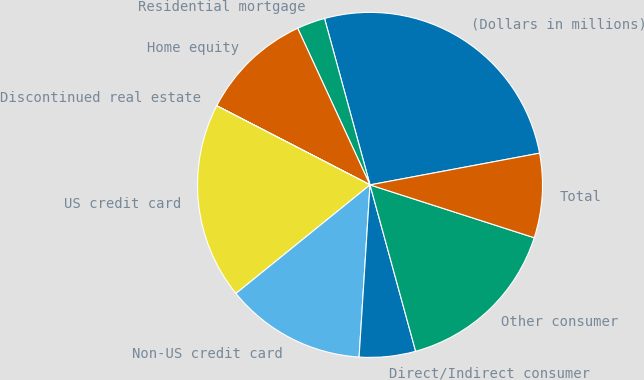Convert chart to OTSL. <chart><loc_0><loc_0><loc_500><loc_500><pie_chart><fcel>(Dollars in millions)<fcel>Residential mortgage<fcel>Home equity<fcel>Discontinued real estate<fcel>US credit card<fcel>Non-US credit card<fcel>Direct/Indirect consumer<fcel>Other consumer<fcel>Total<nl><fcel>26.31%<fcel>2.64%<fcel>10.53%<fcel>0.01%<fcel>18.42%<fcel>13.16%<fcel>5.27%<fcel>15.79%<fcel>7.9%<nl></chart> 